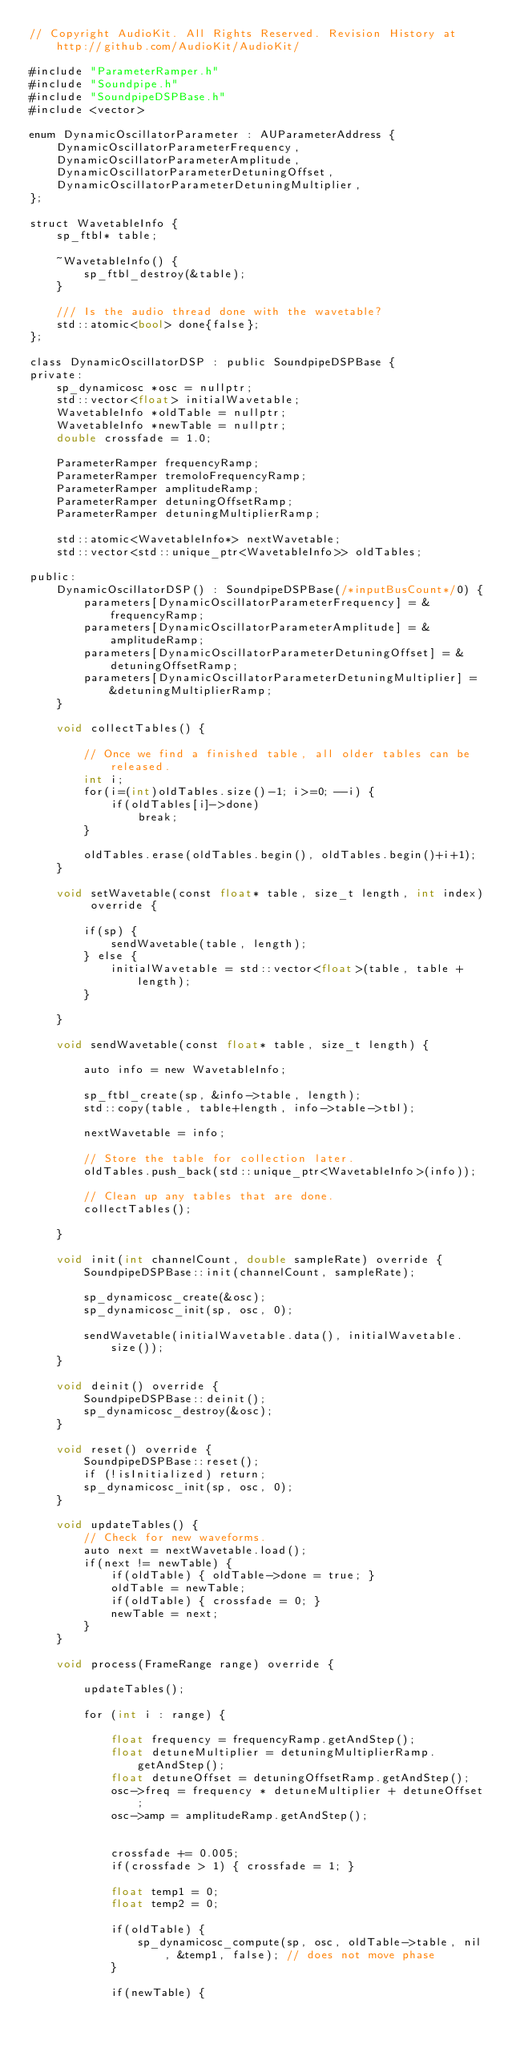<code> <loc_0><loc_0><loc_500><loc_500><_ObjectiveC_>// Copyright AudioKit. All Rights Reserved. Revision History at http://github.com/AudioKit/AudioKit/

#include "ParameterRamper.h"
#include "Soundpipe.h"
#include "SoundpipeDSPBase.h"
#include <vector>

enum DynamicOscillatorParameter : AUParameterAddress {
    DynamicOscillatorParameterFrequency,
    DynamicOscillatorParameterAmplitude,
    DynamicOscillatorParameterDetuningOffset,
    DynamicOscillatorParameterDetuningMultiplier,
};

struct WavetableInfo {
    sp_ftbl* table;

    ~WavetableInfo() {
        sp_ftbl_destroy(&table);
    }

    /// Is the audio thread done with the wavetable?
    std::atomic<bool> done{false};
};

class DynamicOscillatorDSP : public SoundpipeDSPBase {
private:
    sp_dynamicosc *osc = nullptr;
    std::vector<float> initialWavetable;
    WavetableInfo *oldTable = nullptr;
    WavetableInfo *newTable = nullptr;
    double crossfade = 1.0;
    
    ParameterRamper frequencyRamp;
    ParameterRamper tremoloFrequencyRamp;
    ParameterRamper amplitudeRamp;
    ParameterRamper detuningOffsetRamp;
    ParameterRamper detuningMultiplierRamp;

    std::atomic<WavetableInfo*> nextWavetable;
    std::vector<std::unique_ptr<WavetableInfo>> oldTables;

public:
    DynamicOscillatorDSP() : SoundpipeDSPBase(/*inputBusCount*/0) {
        parameters[DynamicOscillatorParameterFrequency] = &frequencyRamp;
        parameters[DynamicOscillatorParameterAmplitude] = &amplitudeRamp;
        parameters[DynamicOscillatorParameterDetuningOffset] = &detuningOffsetRamp;
        parameters[DynamicOscillatorParameterDetuningMultiplier] = &detuningMultiplierRamp;
    }

    void collectTables() {

        // Once we find a finished table, all older tables can be released.
        int i;
        for(i=(int)oldTables.size()-1; i>=0; --i) {
            if(oldTables[i]->done)
                break;
        }

        oldTables.erase(oldTables.begin(), oldTables.begin()+i+1);
    }

    void setWavetable(const float* table, size_t length, int index) override {

        if(sp) {
            sendWavetable(table, length);
        } else {
            initialWavetable = std::vector<float>(table, table + length);
        }

    }

    void sendWavetable(const float* table, size_t length) {

        auto info = new WavetableInfo;

        sp_ftbl_create(sp, &info->table, length);
        std::copy(table, table+length, info->table->tbl);

        nextWavetable = info;

        // Store the table for collection later.
        oldTables.push_back(std::unique_ptr<WavetableInfo>(info));

        // Clean up any tables that are done.
        collectTables();

    }

    void init(int channelCount, double sampleRate) override {
        SoundpipeDSPBase::init(channelCount, sampleRate);

        sp_dynamicosc_create(&osc);
        sp_dynamicosc_init(sp, osc, 0);

        sendWavetable(initialWavetable.data(), initialWavetable.size());
    }

    void deinit() override {
        SoundpipeDSPBase::deinit();
        sp_dynamicosc_destroy(&osc);
    }

    void reset() override {
        SoundpipeDSPBase::reset();
        if (!isInitialized) return;
        sp_dynamicosc_init(sp, osc, 0);
    }

    void updateTables() {
        // Check for new waveforms.
        auto next = nextWavetable.load();
        if(next != newTable) {
            if(oldTable) { oldTable->done = true; }
            oldTable = newTable;
            if(oldTable) { crossfade = 0; }
            newTable = next;
        }
    }

    void process(FrameRange range) override {

        updateTables();

        for (int i : range) {
            
            float frequency = frequencyRamp.getAndStep();
            float detuneMultiplier = detuningMultiplierRamp.getAndStep();
            float detuneOffset = detuningOffsetRamp.getAndStep();
            osc->freq = frequency * detuneMultiplier + detuneOffset;
            osc->amp = amplitudeRamp.getAndStep();


            crossfade += 0.005;
            if(crossfade > 1) { crossfade = 1; }
            
            float temp1 = 0;
            float temp2 = 0;
            
            if(oldTable) {
                sp_dynamicosc_compute(sp, osc, oldTable->table, nil, &temp1, false); // does not move phase
            }
            
            if(newTable) {</code> 